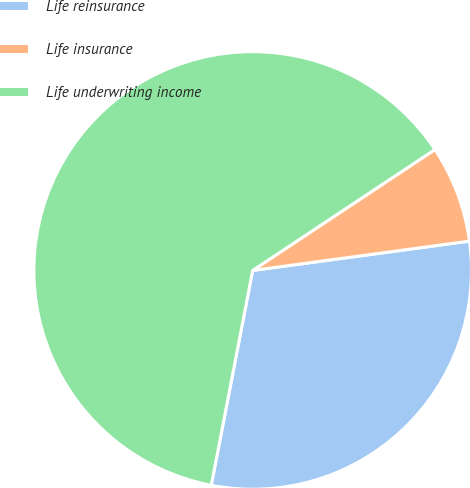<chart> <loc_0><loc_0><loc_500><loc_500><pie_chart><fcel>Life reinsurance<fcel>Life insurance<fcel>Life underwriting income<nl><fcel>30.17%<fcel>7.18%<fcel>62.64%<nl></chart> 